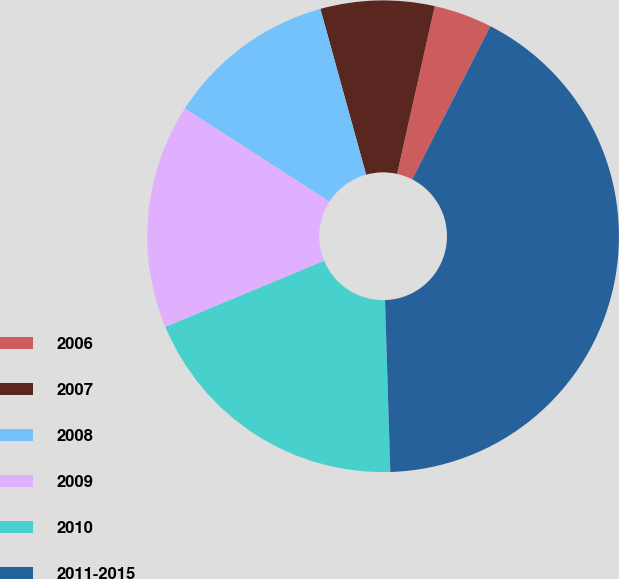Convert chart to OTSL. <chart><loc_0><loc_0><loc_500><loc_500><pie_chart><fcel>2006<fcel>2007<fcel>2008<fcel>2009<fcel>2010<fcel>2011-2015<nl><fcel>4.0%<fcel>7.8%<fcel>11.6%<fcel>15.4%<fcel>19.2%<fcel>42.0%<nl></chart> 